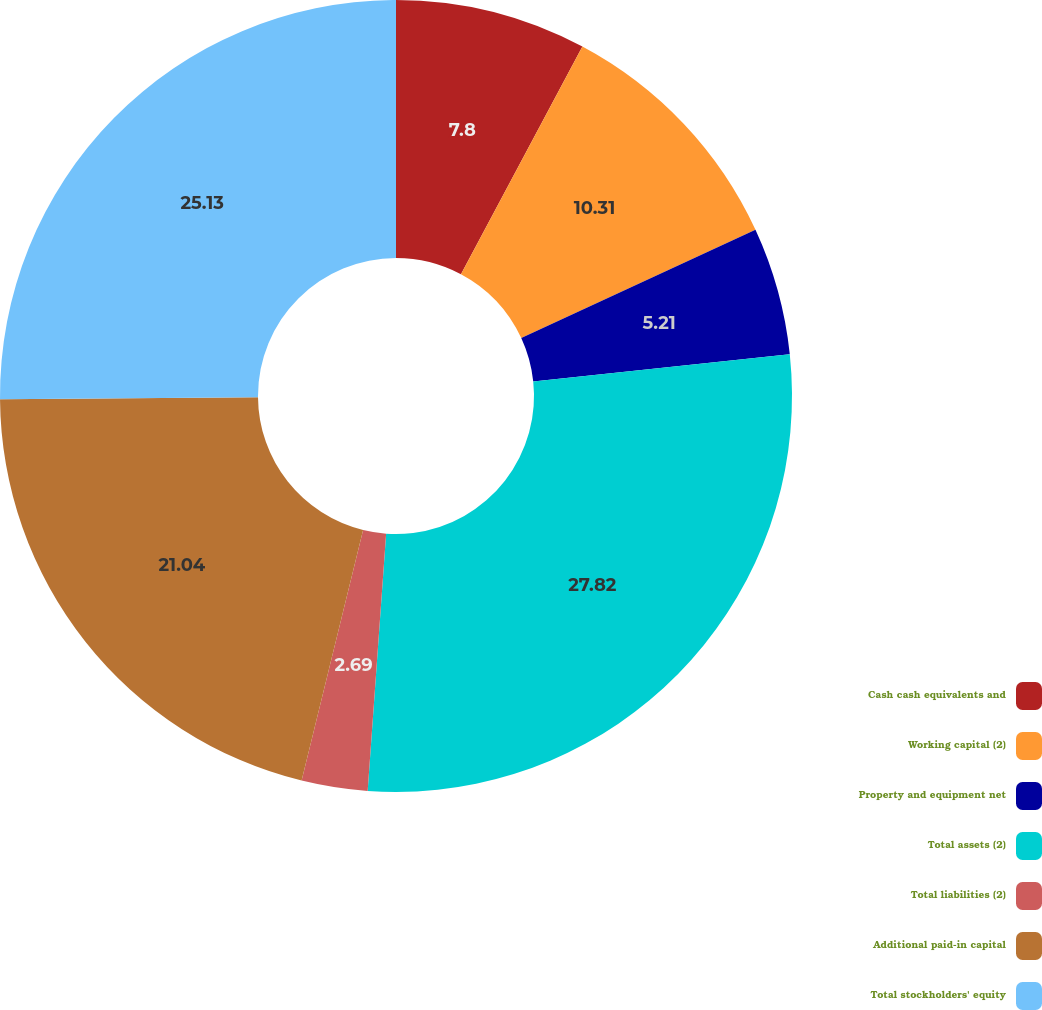<chart> <loc_0><loc_0><loc_500><loc_500><pie_chart><fcel>Cash cash equivalents and<fcel>Working capital (2)<fcel>Property and equipment net<fcel>Total assets (2)<fcel>Total liabilities (2)<fcel>Additional paid-in capital<fcel>Total stockholders' equity<nl><fcel>7.8%<fcel>10.31%<fcel>5.21%<fcel>27.82%<fcel>2.69%<fcel>21.04%<fcel>25.13%<nl></chart> 